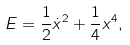Convert formula to latex. <formula><loc_0><loc_0><loc_500><loc_500>E = \frac { 1 } { 2 } \dot { x } ^ { 2 } + \frac { 1 } { 4 } x ^ { 4 } ,</formula> 